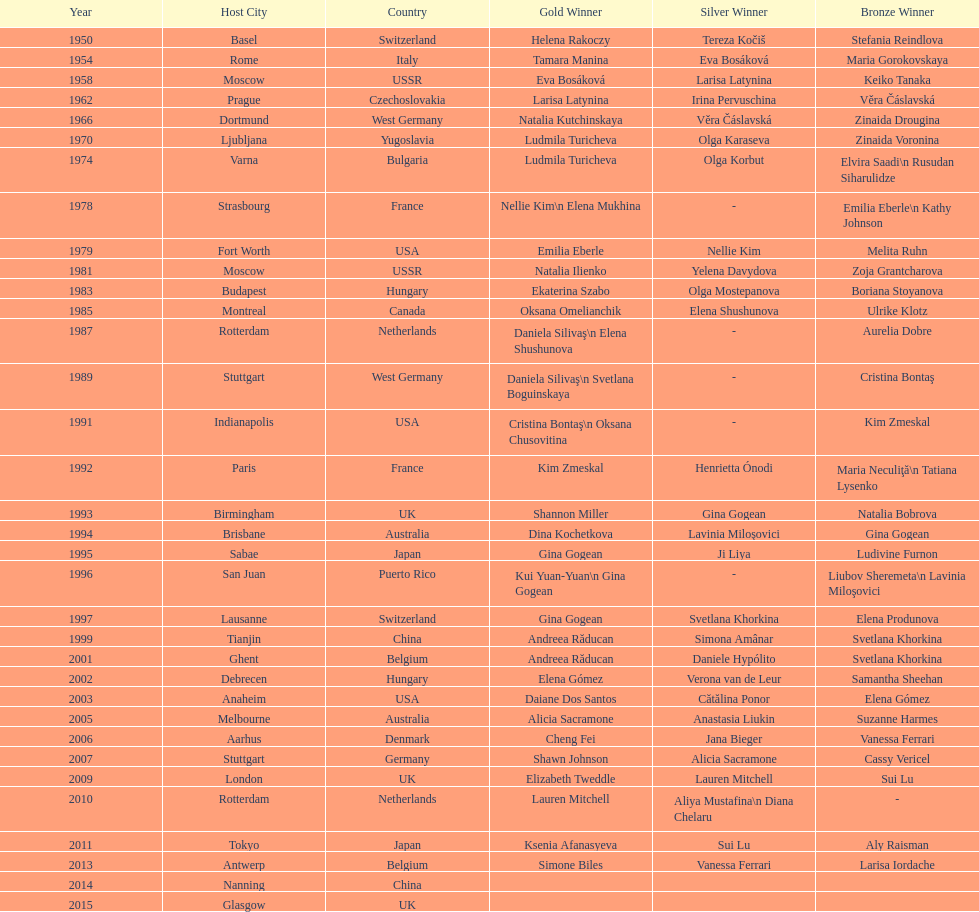How many times was the location in the united states? 3. 